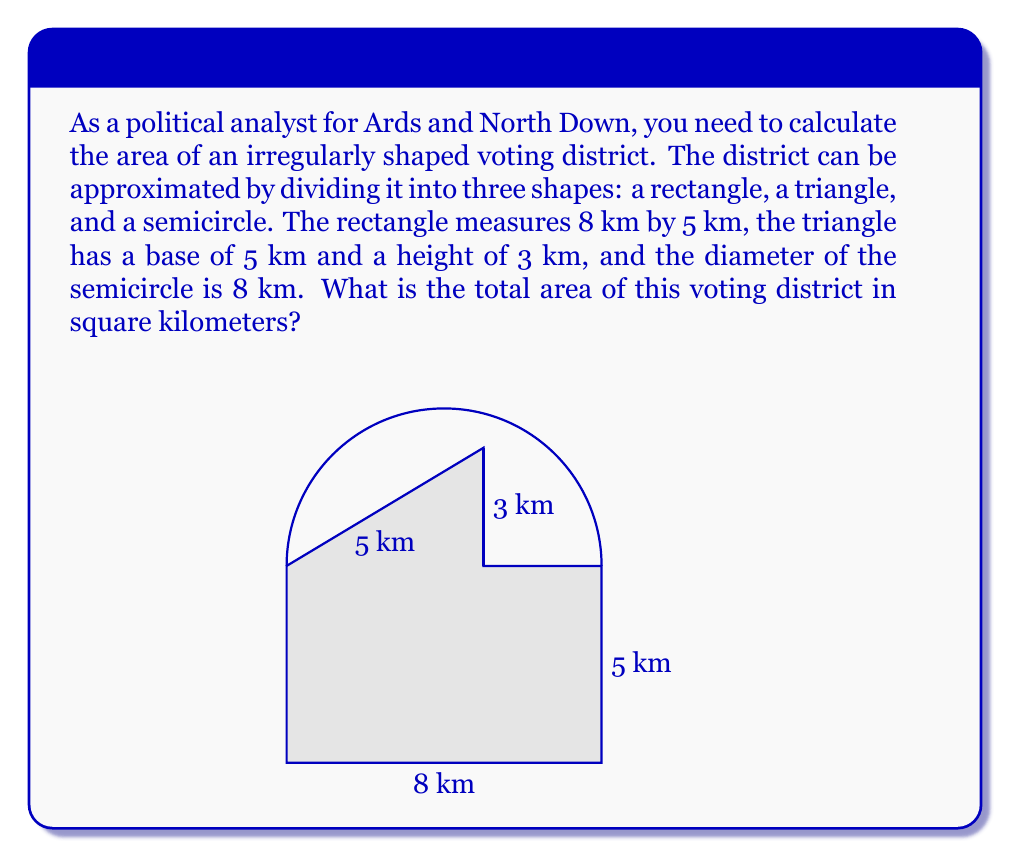Show me your answer to this math problem. To calculate the total area of the voting district, we need to find the areas of each component shape and sum them up:

1. Rectangle:
   Area = length × width
   $A_r = 8 \text{ km} \times 5 \text{ km} = 40 \text{ km}^2$

2. Triangle:
   Area = $\frac{1}{2} \times$ base × height
   $A_t = \frac{1}{2} \times 5 \text{ km} \times 3 \text{ km} = 7.5 \text{ km}^2$

3. Semicircle:
   Area = $\frac{1}{2} \times \pi r^2$, where $r$ is the radius (half the diameter)
   $r = 8 \text{ km} \div 2 = 4 \text{ km}$
   $A_s = \frac{1}{2} \times \pi \times (4 \text{ km})^2 = 8\pi \text{ km}^2$

Now, we sum up all the areas:

$A_\text{total} = A_r + A_t + A_s$
$A_\text{total} = 40 \text{ km}^2 + 7.5 \text{ km}^2 + 8\pi \text{ km}^2$
$A_\text{total} = 47.5 + 8\pi \text{ km}^2$

To get a numerical value, we can use $\pi \approx 3.14159$:

$A_\text{total} \approx 47.5 + 8 \times 3.14159 \text{ km}^2$
$A_\text{total} \approx 47.5 + 25.13272 \text{ km}^2$
$A_\text{total} \approx 72.63272 \text{ km}^2$

Rounding to two decimal places:
$A_\text{total} \approx 72.63 \text{ km}^2$
Answer: $72.63 \text{ km}^2$ 